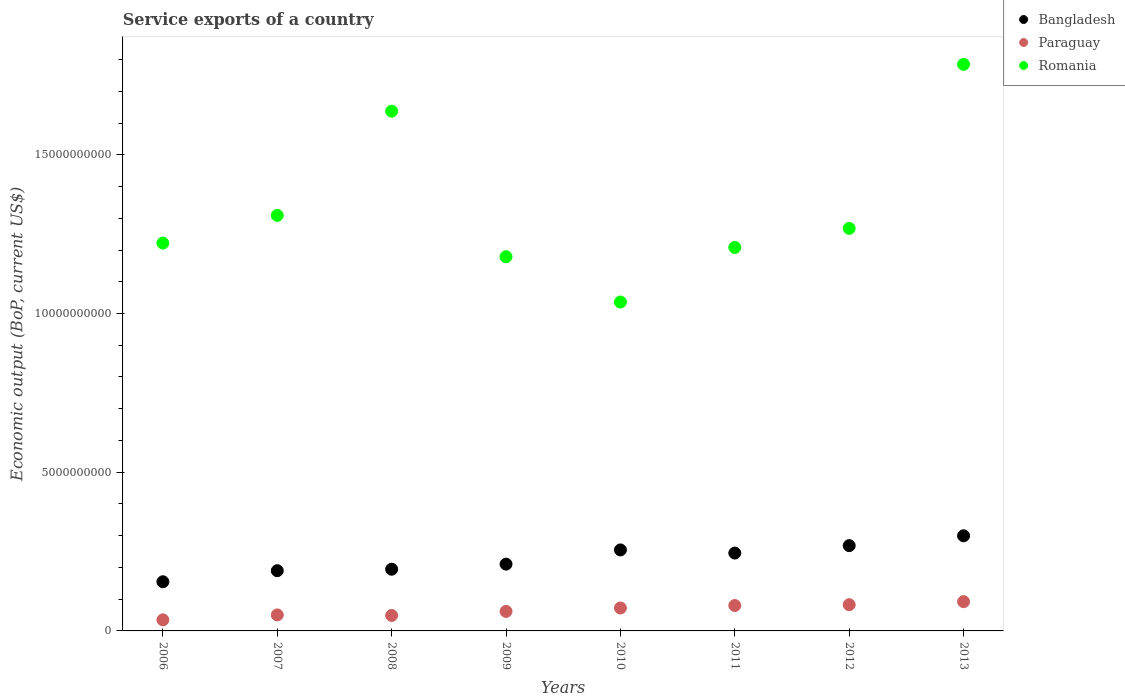How many different coloured dotlines are there?
Make the answer very short. 3. Is the number of dotlines equal to the number of legend labels?
Offer a very short reply. Yes. What is the service exports in Paraguay in 2008?
Your answer should be very brief. 4.87e+08. Across all years, what is the maximum service exports in Bangladesh?
Keep it short and to the point. 3.00e+09. Across all years, what is the minimum service exports in Paraguay?
Ensure brevity in your answer.  3.49e+08. In which year was the service exports in Paraguay maximum?
Ensure brevity in your answer.  2013. What is the total service exports in Romania in the graph?
Give a very brief answer. 1.06e+11. What is the difference between the service exports in Romania in 2009 and that in 2010?
Offer a terse response. 1.43e+09. What is the difference between the service exports in Paraguay in 2011 and the service exports in Romania in 2010?
Your answer should be compact. -9.56e+09. What is the average service exports in Paraguay per year?
Give a very brief answer. 6.53e+08. In the year 2011, what is the difference between the service exports in Bangladesh and service exports in Romania?
Provide a short and direct response. -9.63e+09. In how many years, is the service exports in Paraguay greater than 9000000000 US$?
Offer a very short reply. 0. What is the ratio of the service exports in Paraguay in 2010 to that in 2012?
Provide a succinct answer. 0.87. Is the service exports in Paraguay in 2009 less than that in 2010?
Give a very brief answer. Yes. Is the difference between the service exports in Bangladesh in 2006 and 2012 greater than the difference between the service exports in Romania in 2006 and 2012?
Give a very brief answer. No. What is the difference between the highest and the second highest service exports in Bangladesh?
Provide a succinct answer. 3.10e+08. What is the difference between the highest and the lowest service exports in Romania?
Ensure brevity in your answer.  7.49e+09. In how many years, is the service exports in Paraguay greater than the average service exports in Paraguay taken over all years?
Your response must be concise. 4. Does the service exports in Bangladesh monotonically increase over the years?
Ensure brevity in your answer.  No. Is the service exports in Paraguay strictly greater than the service exports in Romania over the years?
Offer a terse response. No. How many dotlines are there?
Your answer should be very brief. 3. How many years are there in the graph?
Offer a very short reply. 8. What is the difference between two consecutive major ticks on the Y-axis?
Provide a succinct answer. 5.00e+09. Are the values on the major ticks of Y-axis written in scientific E-notation?
Make the answer very short. No. Where does the legend appear in the graph?
Your answer should be very brief. Top right. What is the title of the graph?
Offer a very short reply. Service exports of a country. Does "Sint Maarten (Dutch part)" appear as one of the legend labels in the graph?
Keep it short and to the point. No. What is the label or title of the X-axis?
Ensure brevity in your answer.  Years. What is the label or title of the Y-axis?
Your response must be concise. Economic output (BoP, current US$). What is the Economic output (BoP, current US$) in Bangladesh in 2006?
Provide a succinct answer. 1.55e+09. What is the Economic output (BoP, current US$) in Paraguay in 2006?
Provide a succinct answer. 3.49e+08. What is the Economic output (BoP, current US$) in Romania in 2006?
Your answer should be very brief. 1.22e+1. What is the Economic output (BoP, current US$) in Bangladesh in 2007?
Offer a terse response. 1.90e+09. What is the Economic output (BoP, current US$) of Paraguay in 2007?
Provide a succinct answer. 5.04e+08. What is the Economic output (BoP, current US$) in Romania in 2007?
Make the answer very short. 1.31e+1. What is the Economic output (BoP, current US$) of Bangladesh in 2008?
Provide a succinct answer. 1.94e+09. What is the Economic output (BoP, current US$) in Paraguay in 2008?
Your response must be concise. 4.87e+08. What is the Economic output (BoP, current US$) of Romania in 2008?
Give a very brief answer. 1.64e+1. What is the Economic output (BoP, current US$) of Bangladesh in 2009?
Make the answer very short. 2.10e+09. What is the Economic output (BoP, current US$) in Paraguay in 2009?
Provide a short and direct response. 6.15e+08. What is the Economic output (BoP, current US$) of Romania in 2009?
Your answer should be compact. 1.18e+1. What is the Economic output (BoP, current US$) in Bangladesh in 2010?
Make the answer very short. 2.55e+09. What is the Economic output (BoP, current US$) of Paraguay in 2010?
Offer a very short reply. 7.23e+08. What is the Economic output (BoP, current US$) of Romania in 2010?
Your answer should be compact. 1.04e+1. What is the Economic output (BoP, current US$) of Bangladesh in 2011?
Your answer should be very brief. 2.45e+09. What is the Economic output (BoP, current US$) in Paraguay in 2011?
Give a very brief answer. 8.00e+08. What is the Economic output (BoP, current US$) in Romania in 2011?
Provide a short and direct response. 1.21e+1. What is the Economic output (BoP, current US$) in Bangladesh in 2012?
Ensure brevity in your answer.  2.69e+09. What is the Economic output (BoP, current US$) in Paraguay in 2012?
Give a very brief answer. 8.27e+08. What is the Economic output (BoP, current US$) in Romania in 2012?
Offer a very short reply. 1.27e+1. What is the Economic output (BoP, current US$) of Bangladesh in 2013?
Provide a succinct answer. 3.00e+09. What is the Economic output (BoP, current US$) of Paraguay in 2013?
Give a very brief answer. 9.22e+08. What is the Economic output (BoP, current US$) of Romania in 2013?
Make the answer very short. 1.78e+1. Across all years, what is the maximum Economic output (BoP, current US$) in Bangladesh?
Provide a succinct answer. 3.00e+09. Across all years, what is the maximum Economic output (BoP, current US$) in Paraguay?
Your answer should be very brief. 9.22e+08. Across all years, what is the maximum Economic output (BoP, current US$) in Romania?
Your answer should be very brief. 1.78e+1. Across all years, what is the minimum Economic output (BoP, current US$) in Bangladesh?
Offer a terse response. 1.55e+09. Across all years, what is the minimum Economic output (BoP, current US$) of Paraguay?
Ensure brevity in your answer.  3.49e+08. Across all years, what is the minimum Economic output (BoP, current US$) in Romania?
Offer a terse response. 1.04e+1. What is the total Economic output (BoP, current US$) in Bangladesh in the graph?
Keep it short and to the point. 1.82e+1. What is the total Economic output (BoP, current US$) of Paraguay in the graph?
Your response must be concise. 5.23e+09. What is the total Economic output (BoP, current US$) of Romania in the graph?
Your answer should be very brief. 1.06e+11. What is the difference between the Economic output (BoP, current US$) in Bangladesh in 2006 and that in 2007?
Ensure brevity in your answer.  -3.48e+08. What is the difference between the Economic output (BoP, current US$) of Paraguay in 2006 and that in 2007?
Make the answer very short. -1.55e+08. What is the difference between the Economic output (BoP, current US$) in Romania in 2006 and that in 2007?
Offer a very short reply. -8.71e+08. What is the difference between the Economic output (BoP, current US$) of Bangladesh in 2006 and that in 2008?
Give a very brief answer. -3.95e+08. What is the difference between the Economic output (BoP, current US$) of Paraguay in 2006 and that in 2008?
Keep it short and to the point. -1.38e+08. What is the difference between the Economic output (BoP, current US$) of Romania in 2006 and that in 2008?
Offer a very short reply. -4.15e+09. What is the difference between the Economic output (BoP, current US$) in Bangladesh in 2006 and that in 2009?
Offer a very short reply. -5.55e+08. What is the difference between the Economic output (BoP, current US$) in Paraguay in 2006 and that in 2009?
Offer a very short reply. -2.66e+08. What is the difference between the Economic output (BoP, current US$) of Romania in 2006 and that in 2009?
Your answer should be very brief. 4.30e+08. What is the difference between the Economic output (BoP, current US$) in Bangladesh in 2006 and that in 2010?
Ensure brevity in your answer.  -1.00e+09. What is the difference between the Economic output (BoP, current US$) of Paraguay in 2006 and that in 2010?
Make the answer very short. -3.74e+08. What is the difference between the Economic output (BoP, current US$) in Romania in 2006 and that in 2010?
Offer a very short reply. 1.86e+09. What is the difference between the Economic output (BoP, current US$) of Bangladesh in 2006 and that in 2011?
Your answer should be very brief. -9.04e+08. What is the difference between the Economic output (BoP, current US$) of Paraguay in 2006 and that in 2011?
Offer a very short reply. -4.51e+08. What is the difference between the Economic output (BoP, current US$) of Romania in 2006 and that in 2011?
Provide a short and direct response. 1.38e+08. What is the difference between the Economic output (BoP, current US$) in Bangladesh in 2006 and that in 2012?
Make the answer very short. -1.14e+09. What is the difference between the Economic output (BoP, current US$) of Paraguay in 2006 and that in 2012?
Offer a terse response. -4.78e+08. What is the difference between the Economic output (BoP, current US$) of Romania in 2006 and that in 2012?
Ensure brevity in your answer.  -4.62e+08. What is the difference between the Economic output (BoP, current US$) in Bangladesh in 2006 and that in 2013?
Offer a terse response. -1.45e+09. What is the difference between the Economic output (BoP, current US$) of Paraguay in 2006 and that in 2013?
Your answer should be very brief. -5.73e+08. What is the difference between the Economic output (BoP, current US$) of Romania in 2006 and that in 2013?
Your answer should be very brief. -5.63e+09. What is the difference between the Economic output (BoP, current US$) of Bangladesh in 2007 and that in 2008?
Give a very brief answer. -4.64e+07. What is the difference between the Economic output (BoP, current US$) in Paraguay in 2007 and that in 2008?
Provide a succinct answer. 1.72e+07. What is the difference between the Economic output (BoP, current US$) in Romania in 2007 and that in 2008?
Your answer should be very brief. -3.28e+09. What is the difference between the Economic output (BoP, current US$) of Bangladesh in 2007 and that in 2009?
Your response must be concise. -2.07e+08. What is the difference between the Economic output (BoP, current US$) in Paraguay in 2007 and that in 2009?
Offer a terse response. -1.11e+08. What is the difference between the Economic output (BoP, current US$) in Romania in 2007 and that in 2009?
Your response must be concise. 1.30e+09. What is the difference between the Economic output (BoP, current US$) in Bangladesh in 2007 and that in 2010?
Offer a very short reply. -6.54e+08. What is the difference between the Economic output (BoP, current US$) in Paraguay in 2007 and that in 2010?
Give a very brief answer. -2.18e+08. What is the difference between the Economic output (BoP, current US$) of Romania in 2007 and that in 2010?
Your answer should be compact. 2.73e+09. What is the difference between the Economic output (BoP, current US$) of Bangladesh in 2007 and that in 2011?
Your response must be concise. -5.56e+08. What is the difference between the Economic output (BoP, current US$) in Paraguay in 2007 and that in 2011?
Your answer should be very brief. -2.96e+08. What is the difference between the Economic output (BoP, current US$) in Romania in 2007 and that in 2011?
Offer a very short reply. 1.01e+09. What is the difference between the Economic output (BoP, current US$) of Bangladesh in 2007 and that in 2012?
Give a very brief answer. -7.90e+08. What is the difference between the Economic output (BoP, current US$) of Paraguay in 2007 and that in 2012?
Your response must be concise. -3.23e+08. What is the difference between the Economic output (BoP, current US$) in Romania in 2007 and that in 2012?
Provide a succinct answer. 4.09e+08. What is the difference between the Economic output (BoP, current US$) in Bangladesh in 2007 and that in 2013?
Provide a short and direct response. -1.10e+09. What is the difference between the Economic output (BoP, current US$) in Paraguay in 2007 and that in 2013?
Your response must be concise. -4.18e+08. What is the difference between the Economic output (BoP, current US$) of Romania in 2007 and that in 2013?
Your answer should be compact. -4.76e+09. What is the difference between the Economic output (BoP, current US$) of Bangladesh in 2008 and that in 2009?
Make the answer very short. -1.61e+08. What is the difference between the Economic output (BoP, current US$) of Paraguay in 2008 and that in 2009?
Ensure brevity in your answer.  -1.28e+08. What is the difference between the Economic output (BoP, current US$) in Romania in 2008 and that in 2009?
Your answer should be very brief. 4.58e+09. What is the difference between the Economic output (BoP, current US$) of Bangladesh in 2008 and that in 2010?
Offer a very short reply. -6.08e+08. What is the difference between the Economic output (BoP, current US$) of Paraguay in 2008 and that in 2010?
Your answer should be very brief. -2.36e+08. What is the difference between the Economic output (BoP, current US$) of Romania in 2008 and that in 2010?
Provide a succinct answer. 6.01e+09. What is the difference between the Economic output (BoP, current US$) in Bangladesh in 2008 and that in 2011?
Your answer should be compact. -5.09e+08. What is the difference between the Economic output (BoP, current US$) of Paraguay in 2008 and that in 2011?
Make the answer very short. -3.13e+08. What is the difference between the Economic output (BoP, current US$) of Romania in 2008 and that in 2011?
Your response must be concise. 4.29e+09. What is the difference between the Economic output (BoP, current US$) in Bangladesh in 2008 and that in 2012?
Your response must be concise. -7.43e+08. What is the difference between the Economic output (BoP, current US$) in Paraguay in 2008 and that in 2012?
Ensure brevity in your answer.  -3.40e+08. What is the difference between the Economic output (BoP, current US$) in Romania in 2008 and that in 2012?
Make the answer very short. 3.69e+09. What is the difference between the Economic output (BoP, current US$) in Bangladesh in 2008 and that in 2013?
Offer a very short reply. -1.05e+09. What is the difference between the Economic output (BoP, current US$) of Paraguay in 2008 and that in 2013?
Offer a terse response. -4.35e+08. What is the difference between the Economic output (BoP, current US$) of Romania in 2008 and that in 2013?
Provide a succinct answer. -1.48e+09. What is the difference between the Economic output (BoP, current US$) of Bangladesh in 2009 and that in 2010?
Keep it short and to the point. -4.47e+08. What is the difference between the Economic output (BoP, current US$) in Paraguay in 2009 and that in 2010?
Offer a terse response. -1.08e+08. What is the difference between the Economic output (BoP, current US$) in Romania in 2009 and that in 2010?
Offer a terse response. 1.43e+09. What is the difference between the Economic output (BoP, current US$) of Bangladesh in 2009 and that in 2011?
Keep it short and to the point. -3.49e+08. What is the difference between the Economic output (BoP, current US$) of Paraguay in 2009 and that in 2011?
Your answer should be very brief. -1.86e+08. What is the difference between the Economic output (BoP, current US$) of Romania in 2009 and that in 2011?
Offer a very short reply. -2.92e+08. What is the difference between the Economic output (BoP, current US$) of Bangladesh in 2009 and that in 2012?
Keep it short and to the point. -5.83e+08. What is the difference between the Economic output (BoP, current US$) of Paraguay in 2009 and that in 2012?
Ensure brevity in your answer.  -2.12e+08. What is the difference between the Economic output (BoP, current US$) of Romania in 2009 and that in 2012?
Your response must be concise. -8.92e+08. What is the difference between the Economic output (BoP, current US$) in Bangladesh in 2009 and that in 2013?
Give a very brief answer. -8.93e+08. What is the difference between the Economic output (BoP, current US$) in Paraguay in 2009 and that in 2013?
Your response must be concise. -3.07e+08. What is the difference between the Economic output (BoP, current US$) in Romania in 2009 and that in 2013?
Provide a short and direct response. -6.06e+09. What is the difference between the Economic output (BoP, current US$) of Bangladesh in 2010 and that in 2011?
Your response must be concise. 9.87e+07. What is the difference between the Economic output (BoP, current US$) of Paraguay in 2010 and that in 2011?
Provide a succinct answer. -7.77e+07. What is the difference between the Economic output (BoP, current US$) of Romania in 2010 and that in 2011?
Your answer should be very brief. -1.72e+09. What is the difference between the Economic output (BoP, current US$) of Bangladesh in 2010 and that in 2012?
Your answer should be compact. -1.35e+08. What is the difference between the Economic output (BoP, current US$) of Paraguay in 2010 and that in 2012?
Provide a short and direct response. -1.04e+08. What is the difference between the Economic output (BoP, current US$) of Romania in 2010 and that in 2012?
Make the answer very short. -2.32e+09. What is the difference between the Economic output (BoP, current US$) in Bangladesh in 2010 and that in 2013?
Your answer should be compact. -4.45e+08. What is the difference between the Economic output (BoP, current US$) in Paraguay in 2010 and that in 2013?
Make the answer very short. -1.99e+08. What is the difference between the Economic output (BoP, current US$) of Romania in 2010 and that in 2013?
Make the answer very short. -7.49e+09. What is the difference between the Economic output (BoP, current US$) of Bangladesh in 2011 and that in 2012?
Your answer should be compact. -2.34e+08. What is the difference between the Economic output (BoP, current US$) in Paraguay in 2011 and that in 2012?
Offer a very short reply. -2.67e+07. What is the difference between the Economic output (BoP, current US$) in Romania in 2011 and that in 2012?
Keep it short and to the point. -6.00e+08. What is the difference between the Economic output (BoP, current US$) in Bangladesh in 2011 and that in 2013?
Provide a short and direct response. -5.44e+08. What is the difference between the Economic output (BoP, current US$) in Paraguay in 2011 and that in 2013?
Your answer should be compact. -1.22e+08. What is the difference between the Economic output (BoP, current US$) of Romania in 2011 and that in 2013?
Provide a short and direct response. -5.77e+09. What is the difference between the Economic output (BoP, current US$) in Bangladesh in 2012 and that in 2013?
Offer a terse response. -3.10e+08. What is the difference between the Economic output (BoP, current US$) of Paraguay in 2012 and that in 2013?
Offer a very short reply. -9.49e+07. What is the difference between the Economic output (BoP, current US$) in Romania in 2012 and that in 2013?
Provide a short and direct response. -5.17e+09. What is the difference between the Economic output (BoP, current US$) of Bangladesh in 2006 and the Economic output (BoP, current US$) of Paraguay in 2007?
Keep it short and to the point. 1.04e+09. What is the difference between the Economic output (BoP, current US$) in Bangladesh in 2006 and the Economic output (BoP, current US$) in Romania in 2007?
Offer a very short reply. -1.15e+1. What is the difference between the Economic output (BoP, current US$) of Paraguay in 2006 and the Economic output (BoP, current US$) of Romania in 2007?
Your response must be concise. -1.27e+1. What is the difference between the Economic output (BoP, current US$) of Bangladesh in 2006 and the Economic output (BoP, current US$) of Paraguay in 2008?
Give a very brief answer. 1.06e+09. What is the difference between the Economic output (BoP, current US$) of Bangladesh in 2006 and the Economic output (BoP, current US$) of Romania in 2008?
Offer a terse response. -1.48e+1. What is the difference between the Economic output (BoP, current US$) in Paraguay in 2006 and the Economic output (BoP, current US$) in Romania in 2008?
Your answer should be very brief. -1.60e+1. What is the difference between the Economic output (BoP, current US$) in Bangladesh in 2006 and the Economic output (BoP, current US$) in Paraguay in 2009?
Offer a very short reply. 9.34e+08. What is the difference between the Economic output (BoP, current US$) in Bangladesh in 2006 and the Economic output (BoP, current US$) in Romania in 2009?
Provide a short and direct response. -1.02e+1. What is the difference between the Economic output (BoP, current US$) in Paraguay in 2006 and the Economic output (BoP, current US$) in Romania in 2009?
Ensure brevity in your answer.  -1.14e+1. What is the difference between the Economic output (BoP, current US$) in Bangladesh in 2006 and the Economic output (BoP, current US$) in Paraguay in 2010?
Your answer should be very brief. 8.26e+08. What is the difference between the Economic output (BoP, current US$) of Bangladesh in 2006 and the Economic output (BoP, current US$) of Romania in 2010?
Offer a very short reply. -8.81e+09. What is the difference between the Economic output (BoP, current US$) of Paraguay in 2006 and the Economic output (BoP, current US$) of Romania in 2010?
Offer a terse response. -1.00e+1. What is the difference between the Economic output (BoP, current US$) of Bangladesh in 2006 and the Economic output (BoP, current US$) of Paraguay in 2011?
Provide a succinct answer. 7.49e+08. What is the difference between the Economic output (BoP, current US$) of Bangladesh in 2006 and the Economic output (BoP, current US$) of Romania in 2011?
Provide a short and direct response. -1.05e+1. What is the difference between the Economic output (BoP, current US$) of Paraguay in 2006 and the Economic output (BoP, current US$) of Romania in 2011?
Provide a short and direct response. -1.17e+1. What is the difference between the Economic output (BoP, current US$) in Bangladesh in 2006 and the Economic output (BoP, current US$) in Paraguay in 2012?
Provide a succinct answer. 7.22e+08. What is the difference between the Economic output (BoP, current US$) in Bangladesh in 2006 and the Economic output (BoP, current US$) in Romania in 2012?
Your response must be concise. -1.11e+1. What is the difference between the Economic output (BoP, current US$) of Paraguay in 2006 and the Economic output (BoP, current US$) of Romania in 2012?
Ensure brevity in your answer.  -1.23e+1. What is the difference between the Economic output (BoP, current US$) in Bangladesh in 2006 and the Economic output (BoP, current US$) in Paraguay in 2013?
Provide a succinct answer. 6.27e+08. What is the difference between the Economic output (BoP, current US$) of Bangladesh in 2006 and the Economic output (BoP, current US$) of Romania in 2013?
Give a very brief answer. -1.63e+1. What is the difference between the Economic output (BoP, current US$) in Paraguay in 2006 and the Economic output (BoP, current US$) in Romania in 2013?
Your answer should be very brief. -1.75e+1. What is the difference between the Economic output (BoP, current US$) in Bangladesh in 2007 and the Economic output (BoP, current US$) in Paraguay in 2008?
Your answer should be very brief. 1.41e+09. What is the difference between the Economic output (BoP, current US$) of Bangladesh in 2007 and the Economic output (BoP, current US$) of Romania in 2008?
Make the answer very short. -1.45e+1. What is the difference between the Economic output (BoP, current US$) in Paraguay in 2007 and the Economic output (BoP, current US$) in Romania in 2008?
Your response must be concise. -1.59e+1. What is the difference between the Economic output (BoP, current US$) in Bangladesh in 2007 and the Economic output (BoP, current US$) in Paraguay in 2009?
Provide a succinct answer. 1.28e+09. What is the difference between the Economic output (BoP, current US$) in Bangladesh in 2007 and the Economic output (BoP, current US$) in Romania in 2009?
Keep it short and to the point. -9.89e+09. What is the difference between the Economic output (BoP, current US$) of Paraguay in 2007 and the Economic output (BoP, current US$) of Romania in 2009?
Provide a short and direct response. -1.13e+1. What is the difference between the Economic output (BoP, current US$) in Bangladesh in 2007 and the Economic output (BoP, current US$) in Paraguay in 2010?
Offer a terse response. 1.17e+09. What is the difference between the Economic output (BoP, current US$) of Bangladesh in 2007 and the Economic output (BoP, current US$) of Romania in 2010?
Give a very brief answer. -8.46e+09. What is the difference between the Economic output (BoP, current US$) in Paraguay in 2007 and the Economic output (BoP, current US$) in Romania in 2010?
Your answer should be compact. -9.86e+09. What is the difference between the Economic output (BoP, current US$) of Bangladesh in 2007 and the Economic output (BoP, current US$) of Paraguay in 2011?
Offer a terse response. 1.10e+09. What is the difference between the Economic output (BoP, current US$) in Bangladesh in 2007 and the Economic output (BoP, current US$) in Romania in 2011?
Ensure brevity in your answer.  -1.02e+1. What is the difference between the Economic output (BoP, current US$) of Paraguay in 2007 and the Economic output (BoP, current US$) of Romania in 2011?
Offer a very short reply. -1.16e+1. What is the difference between the Economic output (BoP, current US$) of Bangladesh in 2007 and the Economic output (BoP, current US$) of Paraguay in 2012?
Offer a terse response. 1.07e+09. What is the difference between the Economic output (BoP, current US$) of Bangladesh in 2007 and the Economic output (BoP, current US$) of Romania in 2012?
Provide a succinct answer. -1.08e+1. What is the difference between the Economic output (BoP, current US$) in Paraguay in 2007 and the Economic output (BoP, current US$) in Romania in 2012?
Provide a succinct answer. -1.22e+1. What is the difference between the Economic output (BoP, current US$) of Bangladesh in 2007 and the Economic output (BoP, current US$) of Paraguay in 2013?
Give a very brief answer. 9.75e+08. What is the difference between the Economic output (BoP, current US$) in Bangladesh in 2007 and the Economic output (BoP, current US$) in Romania in 2013?
Offer a terse response. -1.60e+1. What is the difference between the Economic output (BoP, current US$) in Paraguay in 2007 and the Economic output (BoP, current US$) in Romania in 2013?
Offer a very short reply. -1.73e+1. What is the difference between the Economic output (BoP, current US$) in Bangladesh in 2008 and the Economic output (BoP, current US$) in Paraguay in 2009?
Keep it short and to the point. 1.33e+09. What is the difference between the Economic output (BoP, current US$) of Bangladesh in 2008 and the Economic output (BoP, current US$) of Romania in 2009?
Provide a short and direct response. -9.85e+09. What is the difference between the Economic output (BoP, current US$) of Paraguay in 2008 and the Economic output (BoP, current US$) of Romania in 2009?
Offer a very short reply. -1.13e+1. What is the difference between the Economic output (BoP, current US$) of Bangladesh in 2008 and the Economic output (BoP, current US$) of Paraguay in 2010?
Offer a very short reply. 1.22e+09. What is the difference between the Economic output (BoP, current US$) of Bangladesh in 2008 and the Economic output (BoP, current US$) of Romania in 2010?
Provide a short and direct response. -8.42e+09. What is the difference between the Economic output (BoP, current US$) in Paraguay in 2008 and the Economic output (BoP, current US$) in Romania in 2010?
Make the answer very short. -9.87e+09. What is the difference between the Economic output (BoP, current US$) in Bangladesh in 2008 and the Economic output (BoP, current US$) in Paraguay in 2011?
Provide a succinct answer. 1.14e+09. What is the difference between the Economic output (BoP, current US$) of Bangladesh in 2008 and the Economic output (BoP, current US$) of Romania in 2011?
Give a very brief answer. -1.01e+1. What is the difference between the Economic output (BoP, current US$) in Paraguay in 2008 and the Economic output (BoP, current US$) in Romania in 2011?
Ensure brevity in your answer.  -1.16e+1. What is the difference between the Economic output (BoP, current US$) of Bangladesh in 2008 and the Economic output (BoP, current US$) of Paraguay in 2012?
Keep it short and to the point. 1.12e+09. What is the difference between the Economic output (BoP, current US$) of Bangladesh in 2008 and the Economic output (BoP, current US$) of Romania in 2012?
Ensure brevity in your answer.  -1.07e+1. What is the difference between the Economic output (BoP, current US$) in Paraguay in 2008 and the Economic output (BoP, current US$) in Romania in 2012?
Your answer should be compact. -1.22e+1. What is the difference between the Economic output (BoP, current US$) of Bangladesh in 2008 and the Economic output (BoP, current US$) of Paraguay in 2013?
Provide a succinct answer. 1.02e+09. What is the difference between the Economic output (BoP, current US$) of Bangladesh in 2008 and the Economic output (BoP, current US$) of Romania in 2013?
Offer a very short reply. -1.59e+1. What is the difference between the Economic output (BoP, current US$) of Paraguay in 2008 and the Economic output (BoP, current US$) of Romania in 2013?
Provide a succinct answer. -1.74e+1. What is the difference between the Economic output (BoP, current US$) of Bangladesh in 2009 and the Economic output (BoP, current US$) of Paraguay in 2010?
Provide a succinct answer. 1.38e+09. What is the difference between the Economic output (BoP, current US$) in Bangladesh in 2009 and the Economic output (BoP, current US$) in Romania in 2010?
Keep it short and to the point. -8.26e+09. What is the difference between the Economic output (BoP, current US$) in Paraguay in 2009 and the Economic output (BoP, current US$) in Romania in 2010?
Keep it short and to the point. -9.75e+09. What is the difference between the Economic output (BoP, current US$) of Bangladesh in 2009 and the Economic output (BoP, current US$) of Paraguay in 2011?
Make the answer very short. 1.30e+09. What is the difference between the Economic output (BoP, current US$) of Bangladesh in 2009 and the Economic output (BoP, current US$) of Romania in 2011?
Make the answer very short. -9.98e+09. What is the difference between the Economic output (BoP, current US$) in Paraguay in 2009 and the Economic output (BoP, current US$) in Romania in 2011?
Offer a very short reply. -1.15e+1. What is the difference between the Economic output (BoP, current US$) in Bangladesh in 2009 and the Economic output (BoP, current US$) in Paraguay in 2012?
Your answer should be very brief. 1.28e+09. What is the difference between the Economic output (BoP, current US$) of Bangladesh in 2009 and the Economic output (BoP, current US$) of Romania in 2012?
Your response must be concise. -1.06e+1. What is the difference between the Economic output (BoP, current US$) in Paraguay in 2009 and the Economic output (BoP, current US$) in Romania in 2012?
Your answer should be compact. -1.21e+1. What is the difference between the Economic output (BoP, current US$) in Bangladesh in 2009 and the Economic output (BoP, current US$) in Paraguay in 2013?
Make the answer very short. 1.18e+09. What is the difference between the Economic output (BoP, current US$) in Bangladesh in 2009 and the Economic output (BoP, current US$) in Romania in 2013?
Make the answer very short. -1.57e+1. What is the difference between the Economic output (BoP, current US$) in Paraguay in 2009 and the Economic output (BoP, current US$) in Romania in 2013?
Keep it short and to the point. -1.72e+1. What is the difference between the Economic output (BoP, current US$) of Bangladesh in 2010 and the Economic output (BoP, current US$) of Paraguay in 2011?
Offer a very short reply. 1.75e+09. What is the difference between the Economic output (BoP, current US$) in Bangladesh in 2010 and the Economic output (BoP, current US$) in Romania in 2011?
Make the answer very short. -9.53e+09. What is the difference between the Economic output (BoP, current US$) of Paraguay in 2010 and the Economic output (BoP, current US$) of Romania in 2011?
Give a very brief answer. -1.14e+1. What is the difference between the Economic output (BoP, current US$) in Bangladesh in 2010 and the Economic output (BoP, current US$) in Paraguay in 2012?
Keep it short and to the point. 1.72e+09. What is the difference between the Economic output (BoP, current US$) in Bangladesh in 2010 and the Economic output (BoP, current US$) in Romania in 2012?
Make the answer very short. -1.01e+1. What is the difference between the Economic output (BoP, current US$) of Paraguay in 2010 and the Economic output (BoP, current US$) of Romania in 2012?
Your response must be concise. -1.20e+1. What is the difference between the Economic output (BoP, current US$) of Bangladesh in 2010 and the Economic output (BoP, current US$) of Paraguay in 2013?
Keep it short and to the point. 1.63e+09. What is the difference between the Economic output (BoP, current US$) of Bangladesh in 2010 and the Economic output (BoP, current US$) of Romania in 2013?
Give a very brief answer. -1.53e+1. What is the difference between the Economic output (BoP, current US$) of Paraguay in 2010 and the Economic output (BoP, current US$) of Romania in 2013?
Keep it short and to the point. -1.71e+1. What is the difference between the Economic output (BoP, current US$) of Bangladesh in 2011 and the Economic output (BoP, current US$) of Paraguay in 2012?
Give a very brief answer. 1.63e+09. What is the difference between the Economic output (BoP, current US$) in Bangladesh in 2011 and the Economic output (BoP, current US$) in Romania in 2012?
Provide a short and direct response. -1.02e+1. What is the difference between the Economic output (BoP, current US$) in Paraguay in 2011 and the Economic output (BoP, current US$) in Romania in 2012?
Your answer should be very brief. -1.19e+1. What is the difference between the Economic output (BoP, current US$) in Bangladesh in 2011 and the Economic output (BoP, current US$) in Paraguay in 2013?
Keep it short and to the point. 1.53e+09. What is the difference between the Economic output (BoP, current US$) in Bangladesh in 2011 and the Economic output (BoP, current US$) in Romania in 2013?
Make the answer very short. -1.54e+1. What is the difference between the Economic output (BoP, current US$) in Paraguay in 2011 and the Economic output (BoP, current US$) in Romania in 2013?
Offer a very short reply. -1.70e+1. What is the difference between the Economic output (BoP, current US$) in Bangladesh in 2012 and the Economic output (BoP, current US$) in Paraguay in 2013?
Ensure brevity in your answer.  1.76e+09. What is the difference between the Economic output (BoP, current US$) of Bangladesh in 2012 and the Economic output (BoP, current US$) of Romania in 2013?
Make the answer very short. -1.52e+1. What is the difference between the Economic output (BoP, current US$) in Paraguay in 2012 and the Economic output (BoP, current US$) in Romania in 2013?
Your answer should be compact. -1.70e+1. What is the average Economic output (BoP, current US$) in Bangladesh per year?
Your response must be concise. 2.27e+09. What is the average Economic output (BoP, current US$) of Paraguay per year?
Ensure brevity in your answer.  6.53e+08. What is the average Economic output (BoP, current US$) of Romania per year?
Ensure brevity in your answer.  1.33e+1. In the year 2006, what is the difference between the Economic output (BoP, current US$) in Bangladesh and Economic output (BoP, current US$) in Paraguay?
Provide a short and direct response. 1.20e+09. In the year 2006, what is the difference between the Economic output (BoP, current US$) of Bangladesh and Economic output (BoP, current US$) of Romania?
Give a very brief answer. -1.07e+1. In the year 2006, what is the difference between the Economic output (BoP, current US$) in Paraguay and Economic output (BoP, current US$) in Romania?
Make the answer very short. -1.19e+1. In the year 2007, what is the difference between the Economic output (BoP, current US$) in Bangladesh and Economic output (BoP, current US$) in Paraguay?
Provide a succinct answer. 1.39e+09. In the year 2007, what is the difference between the Economic output (BoP, current US$) of Bangladesh and Economic output (BoP, current US$) of Romania?
Your answer should be compact. -1.12e+1. In the year 2007, what is the difference between the Economic output (BoP, current US$) of Paraguay and Economic output (BoP, current US$) of Romania?
Provide a short and direct response. -1.26e+1. In the year 2008, what is the difference between the Economic output (BoP, current US$) of Bangladesh and Economic output (BoP, current US$) of Paraguay?
Give a very brief answer. 1.46e+09. In the year 2008, what is the difference between the Economic output (BoP, current US$) of Bangladesh and Economic output (BoP, current US$) of Romania?
Your response must be concise. -1.44e+1. In the year 2008, what is the difference between the Economic output (BoP, current US$) in Paraguay and Economic output (BoP, current US$) in Romania?
Offer a very short reply. -1.59e+1. In the year 2009, what is the difference between the Economic output (BoP, current US$) of Bangladesh and Economic output (BoP, current US$) of Paraguay?
Provide a short and direct response. 1.49e+09. In the year 2009, what is the difference between the Economic output (BoP, current US$) in Bangladesh and Economic output (BoP, current US$) in Romania?
Provide a succinct answer. -9.68e+09. In the year 2009, what is the difference between the Economic output (BoP, current US$) in Paraguay and Economic output (BoP, current US$) in Romania?
Provide a short and direct response. -1.12e+1. In the year 2010, what is the difference between the Economic output (BoP, current US$) of Bangladesh and Economic output (BoP, current US$) of Paraguay?
Ensure brevity in your answer.  1.83e+09. In the year 2010, what is the difference between the Economic output (BoP, current US$) of Bangladesh and Economic output (BoP, current US$) of Romania?
Keep it short and to the point. -7.81e+09. In the year 2010, what is the difference between the Economic output (BoP, current US$) of Paraguay and Economic output (BoP, current US$) of Romania?
Make the answer very short. -9.64e+09. In the year 2011, what is the difference between the Economic output (BoP, current US$) in Bangladesh and Economic output (BoP, current US$) in Paraguay?
Keep it short and to the point. 1.65e+09. In the year 2011, what is the difference between the Economic output (BoP, current US$) of Bangladesh and Economic output (BoP, current US$) of Romania?
Ensure brevity in your answer.  -9.63e+09. In the year 2011, what is the difference between the Economic output (BoP, current US$) of Paraguay and Economic output (BoP, current US$) of Romania?
Give a very brief answer. -1.13e+1. In the year 2012, what is the difference between the Economic output (BoP, current US$) in Bangladesh and Economic output (BoP, current US$) in Paraguay?
Keep it short and to the point. 1.86e+09. In the year 2012, what is the difference between the Economic output (BoP, current US$) in Bangladesh and Economic output (BoP, current US$) in Romania?
Make the answer very short. -9.99e+09. In the year 2012, what is the difference between the Economic output (BoP, current US$) of Paraguay and Economic output (BoP, current US$) of Romania?
Provide a succinct answer. -1.19e+1. In the year 2013, what is the difference between the Economic output (BoP, current US$) in Bangladesh and Economic output (BoP, current US$) in Paraguay?
Make the answer very short. 2.07e+09. In the year 2013, what is the difference between the Economic output (BoP, current US$) in Bangladesh and Economic output (BoP, current US$) in Romania?
Your answer should be very brief. -1.49e+1. In the year 2013, what is the difference between the Economic output (BoP, current US$) in Paraguay and Economic output (BoP, current US$) in Romania?
Make the answer very short. -1.69e+1. What is the ratio of the Economic output (BoP, current US$) of Bangladesh in 2006 to that in 2007?
Ensure brevity in your answer.  0.82. What is the ratio of the Economic output (BoP, current US$) in Paraguay in 2006 to that in 2007?
Your response must be concise. 0.69. What is the ratio of the Economic output (BoP, current US$) of Romania in 2006 to that in 2007?
Your response must be concise. 0.93. What is the ratio of the Economic output (BoP, current US$) in Bangladesh in 2006 to that in 2008?
Offer a terse response. 0.8. What is the ratio of the Economic output (BoP, current US$) of Paraguay in 2006 to that in 2008?
Offer a terse response. 0.72. What is the ratio of the Economic output (BoP, current US$) in Romania in 2006 to that in 2008?
Ensure brevity in your answer.  0.75. What is the ratio of the Economic output (BoP, current US$) in Bangladesh in 2006 to that in 2009?
Offer a very short reply. 0.74. What is the ratio of the Economic output (BoP, current US$) of Paraguay in 2006 to that in 2009?
Make the answer very short. 0.57. What is the ratio of the Economic output (BoP, current US$) of Romania in 2006 to that in 2009?
Keep it short and to the point. 1.04. What is the ratio of the Economic output (BoP, current US$) of Bangladesh in 2006 to that in 2010?
Offer a terse response. 0.61. What is the ratio of the Economic output (BoP, current US$) of Paraguay in 2006 to that in 2010?
Your response must be concise. 0.48. What is the ratio of the Economic output (BoP, current US$) of Romania in 2006 to that in 2010?
Ensure brevity in your answer.  1.18. What is the ratio of the Economic output (BoP, current US$) of Bangladesh in 2006 to that in 2011?
Make the answer very short. 0.63. What is the ratio of the Economic output (BoP, current US$) in Paraguay in 2006 to that in 2011?
Provide a succinct answer. 0.44. What is the ratio of the Economic output (BoP, current US$) in Romania in 2006 to that in 2011?
Your answer should be compact. 1.01. What is the ratio of the Economic output (BoP, current US$) in Bangladesh in 2006 to that in 2012?
Provide a short and direct response. 0.58. What is the ratio of the Economic output (BoP, current US$) in Paraguay in 2006 to that in 2012?
Provide a short and direct response. 0.42. What is the ratio of the Economic output (BoP, current US$) of Romania in 2006 to that in 2012?
Offer a very short reply. 0.96. What is the ratio of the Economic output (BoP, current US$) of Bangladesh in 2006 to that in 2013?
Offer a terse response. 0.52. What is the ratio of the Economic output (BoP, current US$) in Paraguay in 2006 to that in 2013?
Your answer should be very brief. 0.38. What is the ratio of the Economic output (BoP, current US$) of Romania in 2006 to that in 2013?
Make the answer very short. 0.68. What is the ratio of the Economic output (BoP, current US$) of Bangladesh in 2007 to that in 2008?
Provide a succinct answer. 0.98. What is the ratio of the Economic output (BoP, current US$) in Paraguay in 2007 to that in 2008?
Your response must be concise. 1.04. What is the ratio of the Economic output (BoP, current US$) of Romania in 2007 to that in 2008?
Your response must be concise. 0.8. What is the ratio of the Economic output (BoP, current US$) in Bangladesh in 2007 to that in 2009?
Make the answer very short. 0.9. What is the ratio of the Economic output (BoP, current US$) in Paraguay in 2007 to that in 2009?
Your response must be concise. 0.82. What is the ratio of the Economic output (BoP, current US$) in Romania in 2007 to that in 2009?
Your answer should be very brief. 1.11. What is the ratio of the Economic output (BoP, current US$) of Bangladesh in 2007 to that in 2010?
Provide a short and direct response. 0.74. What is the ratio of the Economic output (BoP, current US$) of Paraguay in 2007 to that in 2010?
Your answer should be very brief. 0.7. What is the ratio of the Economic output (BoP, current US$) in Romania in 2007 to that in 2010?
Your answer should be very brief. 1.26. What is the ratio of the Economic output (BoP, current US$) of Bangladesh in 2007 to that in 2011?
Keep it short and to the point. 0.77. What is the ratio of the Economic output (BoP, current US$) of Paraguay in 2007 to that in 2011?
Provide a succinct answer. 0.63. What is the ratio of the Economic output (BoP, current US$) of Romania in 2007 to that in 2011?
Your answer should be very brief. 1.08. What is the ratio of the Economic output (BoP, current US$) in Bangladesh in 2007 to that in 2012?
Offer a terse response. 0.71. What is the ratio of the Economic output (BoP, current US$) of Paraguay in 2007 to that in 2012?
Ensure brevity in your answer.  0.61. What is the ratio of the Economic output (BoP, current US$) of Romania in 2007 to that in 2012?
Your answer should be very brief. 1.03. What is the ratio of the Economic output (BoP, current US$) of Bangladesh in 2007 to that in 2013?
Offer a very short reply. 0.63. What is the ratio of the Economic output (BoP, current US$) in Paraguay in 2007 to that in 2013?
Provide a short and direct response. 0.55. What is the ratio of the Economic output (BoP, current US$) in Romania in 2007 to that in 2013?
Keep it short and to the point. 0.73. What is the ratio of the Economic output (BoP, current US$) of Bangladesh in 2008 to that in 2009?
Offer a very short reply. 0.92. What is the ratio of the Economic output (BoP, current US$) of Paraguay in 2008 to that in 2009?
Your answer should be very brief. 0.79. What is the ratio of the Economic output (BoP, current US$) in Romania in 2008 to that in 2009?
Keep it short and to the point. 1.39. What is the ratio of the Economic output (BoP, current US$) in Bangladesh in 2008 to that in 2010?
Make the answer very short. 0.76. What is the ratio of the Economic output (BoP, current US$) in Paraguay in 2008 to that in 2010?
Make the answer very short. 0.67. What is the ratio of the Economic output (BoP, current US$) in Romania in 2008 to that in 2010?
Make the answer very short. 1.58. What is the ratio of the Economic output (BoP, current US$) of Bangladesh in 2008 to that in 2011?
Provide a succinct answer. 0.79. What is the ratio of the Economic output (BoP, current US$) of Paraguay in 2008 to that in 2011?
Provide a short and direct response. 0.61. What is the ratio of the Economic output (BoP, current US$) in Romania in 2008 to that in 2011?
Offer a very short reply. 1.36. What is the ratio of the Economic output (BoP, current US$) in Bangladesh in 2008 to that in 2012?
Provide a succinct answer. 0.72. What is the ratio of the Economic output (BoP, current US$) of Paraguay in 2008 to that in 2012?
Keep it short and to the point. 0.59. What is the ratio of the Economic output (BoP, current US$) in Romania in 2008 to that in 2012?
Provide a short and direct response. 1.29. What is the ratio of the Economic output (BoP, current US$) in Bangladesh in 2008 to that in 2013?
Ensure brevity in your answer.  0.65. What is the ratio of the Economic output (BoP, current US$) of Paraguay in 2008 to that in 2013?
Your response must be concise. 0.53. What is the ratio of the Economic output (BoP, current US$) in Romania in 2008 to that in 2013?
Make the answer very short. 0.92. What is the ratio of the Economic output (BoP, current US$) in Bangladesh in 2009 to that in 2010?
Give a very brief answer. 0.82. What is the ratio of the Economic output (BoP, current US$) of Paraguay in 2009 to that in 2010?
Your answer should be very brief. 0.85. What is the ratio of the Economic output (BoP, current US$) of Romania in 2009 to that in 2010?
Offer a terse response. 1.14. What is the ratio of the Economic output (BoP, current US$) in Bangladesh in 2009 to that in 2011?
Provide a short and direct response. 0.86. What is the ratio of the Economic output (BoP, current US$) of Paraguay in 2009 to that in 2011?
Ensure brevity in your answer.  0.77. What is the ratio of the Economic output (BoP, current US$) of Romania in 2009 to that in 2011?
Provide a short and direct response. 0.98. What is the ratio of the Economic output (BoP, current US$) in Bangladesh in 2009 to that in 2012?
Make the answer very short. 0.78. What is the ratio of the Economic output (BoP, current US$) of Paraguay in 2009 to that in 2012?
Provide a succinct answer. 0.74. What is the ratio of the Economic output (BoP, current US$) of Romania in 2009 to that in 2012?
Provide a short and direct response. 0.93. What is the ratio of the Economic output (BoP, current US$) of Bangladesh in 2009 to that in 2013?
Your answer should be very brief. 0.7. What is the ratio of the Economic output (BoP, current US$) in Paraguay in 2009 to that in 2013?
Keep it short and to the point. 0.67. What is the ratio of the Economic output (BoP, current US$) of Romania in 2009 to that in 2013?
Offer a very short reply. 0.66. What is the ratio of the Economic output (BoP, current US$) of Bangladesh in 2010 to that in 2011?
Make the answer very short. 1.04. What is the ratio of the Economic output (BoP, current US$) in Paraguay in 2010 to that in 2011?
Your response must be concise. 0.9. What is the ratio of the Economic output (BoP, current US$) of Romania in 2010 to that in 2011?
Provide a short and direct response. 0.86. What is the ratio of the Economic output (BoP, current US$) of Bangladesh in 2010 to that in 2012?
Provide a short and direct response. 0.95. What is the ratio of the Economic output (BoP, current US$) in Paraguay in 2010 to that in 2012?
Make the answer very short. 0.87. What is the ratio of the Economic output (BoP, current US$) in Romania in 2010 to that in 2012?
Provide a short and direct response. 0.82. What is the ratio of the Economic output (BoP, current US$) of Bangladesh in 2010 to that in 2013?
Make the answer very short. 0.85. What is the ratio of the Economic output (BoP, current US$) of Paraguay in 2010 to that in 2013?
Your answer should be compact. 0.78. What is the ratio of the Economic output (BoP, current US$) of Romania in 2010 to that in 2013?
Offer a terse response. 0.58. What is the ratio of the Economic output (BoP, current US$) of Bangladesh in 2011 to that in 2012?
Keep it short and to the point. 0.91. What is the ratio of the Economic output (BoP, current US$) of Romania in 2011 to that in 2012?
Ensure brevity in your answer.  0.95. What is the ratio of the Economic output (BoP, current US$) of Bangladesh in 2011 to that in 2013?
Your answer should be very brief. 0.82. What is the ratio of the Economic output (BoP, current US$) of Paraguay in 2011 to that in 2013?
Offer a very short reply. 0.87. What is the ratio of the Economic output (BoP, current US$) of Romania in 2011 to that in 2013?
Your answer should be very brief. 0.68. What is the ratio of the Economic output (BoP, current US$) in Bangladesh in 2012 to that in 2013?
Offer a terse response. 0.9. What is the ratio of the Economic output (BoP, current US$) of Paraguay in 2012 to that in 2013?
Your answer should be compact. 0.9. What is the ratio of the Economic output (BoP, current US$) in Romania in 2012 to that in 2013?
Provide a succinct answer. 0.71. What is the difference between the highest and the second highest Economic output (BoP, current US$) of Bangladesh?
Give a very brief answer. 3.10e+08. What is the difference between the highest and the second highest Economic output (BoP, current US$) of Paraguay?
Offer a very short reply. 9.49e+07. What is the difference between the highest and the second highest Economic output (BoP, current US$) in Romania?
Your answer should be very brief. 1.48e+09. What is the difference between the highest and the lowest Economic output (BoP, current US$) of Bangladesh?
Your response must be concise. 1.45e+09. What is the difference between the highest and the lowest Economic output (BoP, current US$) of Paraguay?
Make the answer very short. 5.73e+08. What is the difference between the highest and the lowest Economic output (BoP, current US$) of Romania?
Your response must be concise. 7.49e+09. 